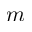Convert formula to latex. <formula><loc_0><loc_0><loc_500><loc_500>m</formula> 